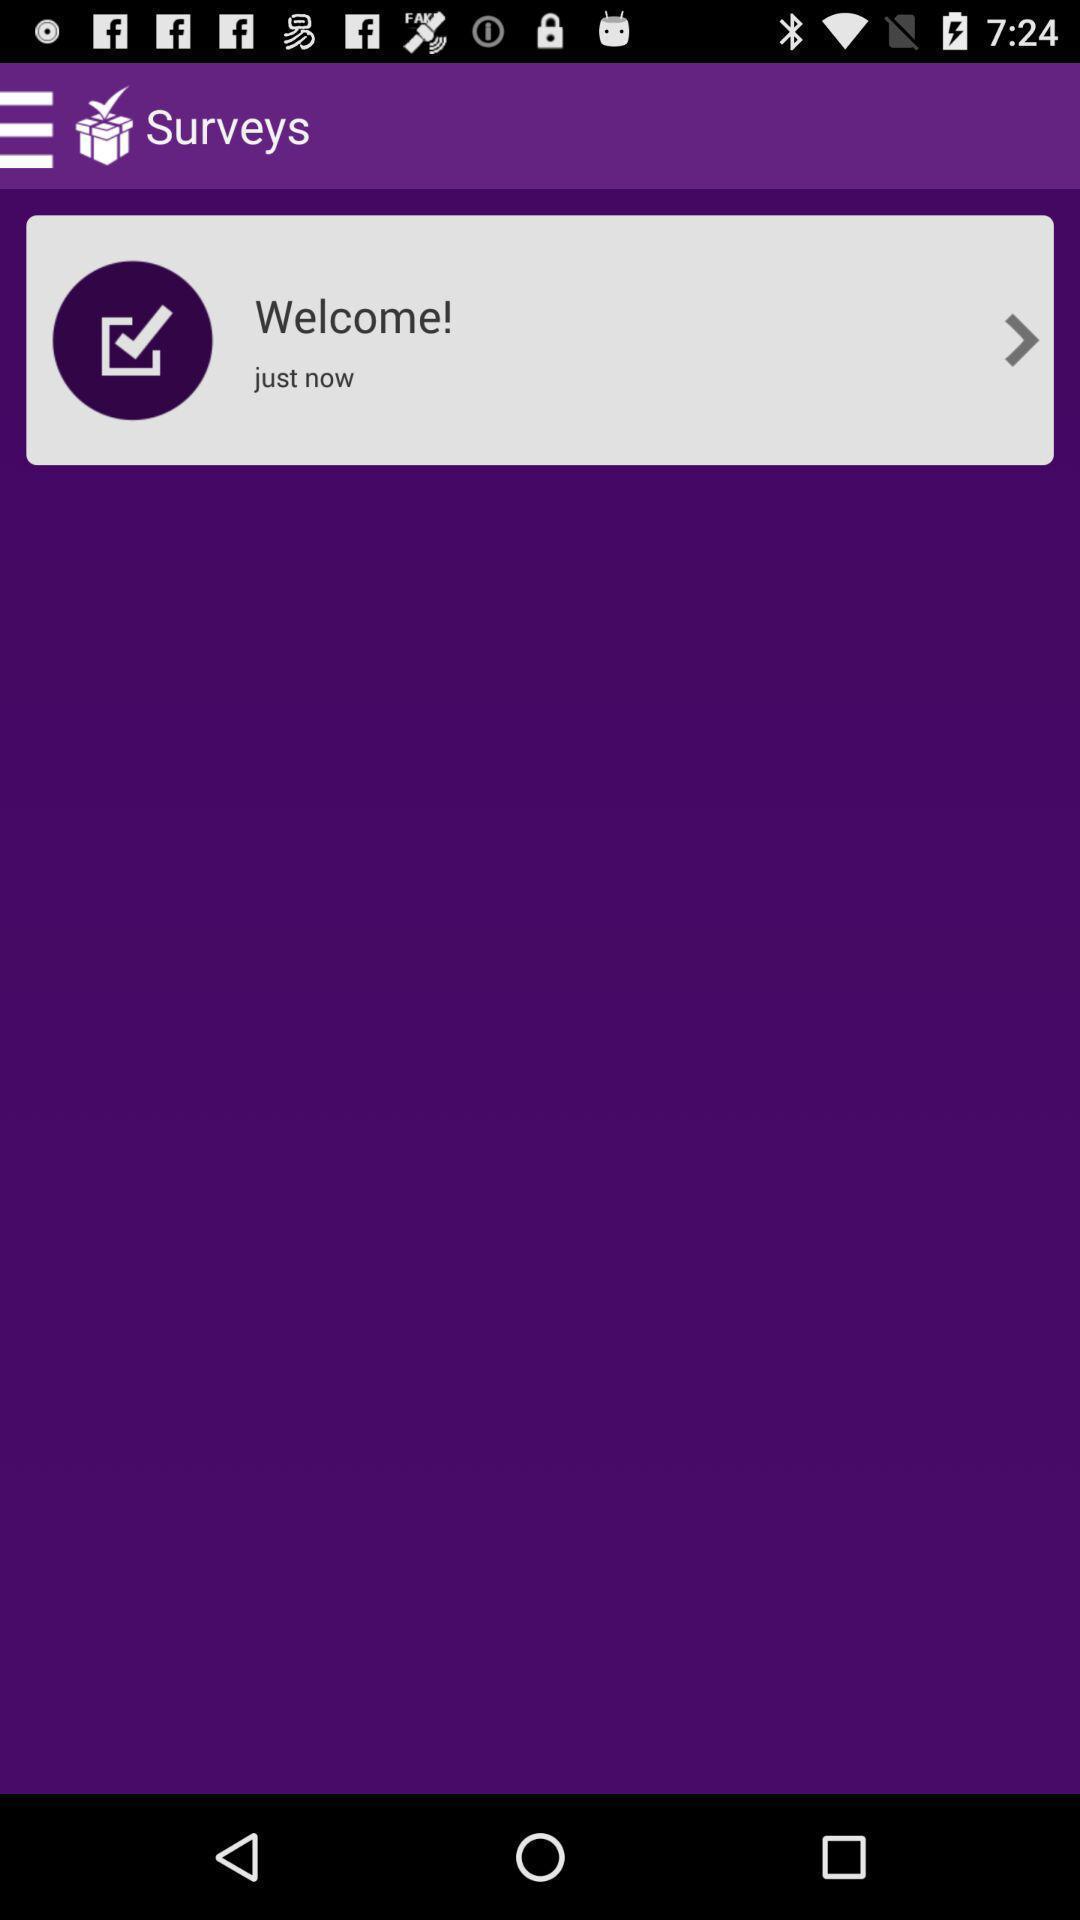Describe this image in words. Welcome page. 